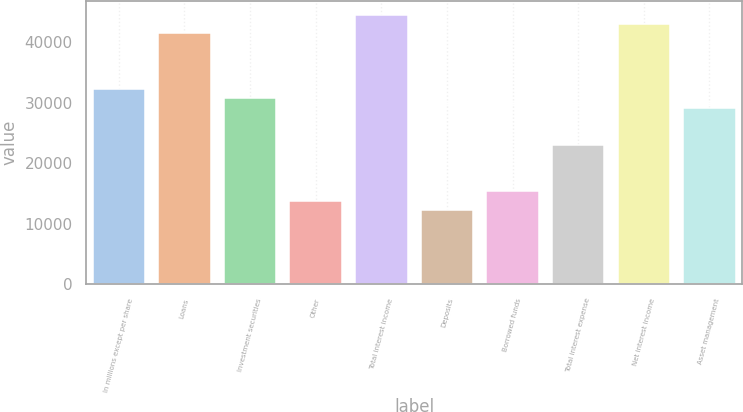Convert chart to OTSL. <chart><loc_0><loc_0><loc_500><loc_500><bar_chart><fcel>In millions except per share<fcel>Loans<fcel>Investment securities<fcel>Other<fcel>Total interest income<fcel>Deposits<fcel>Borrowed funds<fcel>Total interest expense<fcel>Net interest income<fcel>Asset management<nl><fcel>32283.1<fcel>41505.7<fcel>30746<fcel>13837.9<fcel>44579.9<fcel>12300.8<fcel>15375<fcel>23060.5<fcel>43042.8<fcel>29208.9<nl></chart> 